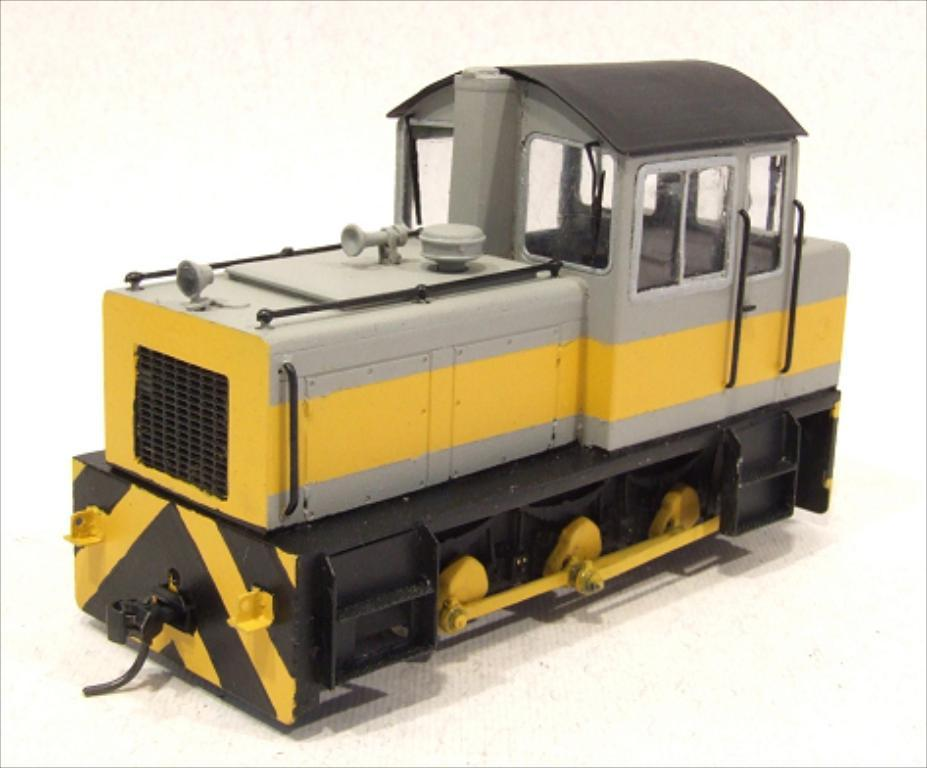What is the main subject of the image? There is a toy train in the image. Where is the toy train located in the image? The toy train is in the center of the image. What type of ray can be seen swimming near the toy train in the image? There is no ray present in the image; it features a toy train in the center. What kind of leaf is covering the toy train in the image? There is no leaf covering the toy train in the image; it is a toy train without any vegetation. 